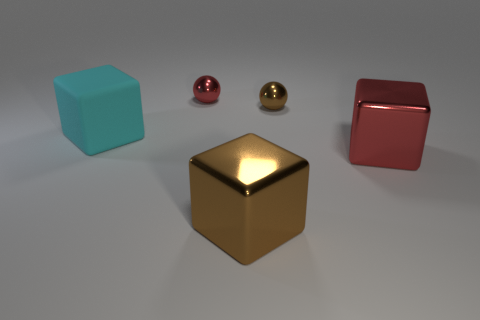Is there any other thing that has the same material as the cyan thing?
Offer a very short reply. No. What shape is the big thing to the left of the sphere to the left of the cube in front of the red block?
Provide a short and direct response. Cube. Are the tiny ball that is right of the red shiny sphere and the cube to the left of the small red shiny thing made of the same material?
Ensure brevity in your answer.  No. What is the brown block made of?
Ensure brevity in your answer.  Metal. What number of other large objects have the same shape as the big red shiny object?
Give a very brief answer. 2. Is there anything else that is the same shape as the tiny brown object?
Give a very brief answer. Yes. There is a shiny sphere behind the small thing that is to the right of the red shiny object that is to the left of the big brown shiny object; what color is it?
Offer a terse response. Red. What number of tiny objects are either red metallic balls or brown things?
Your response must be concise. 2. Is the number of metal spheres that are behind the small red metallic object the same as the number of large cyan cylinders?
Offer a terse response. Yes. Are there any brown metal things in front of the small brown ball?
Your answer should be compact. Yes. 